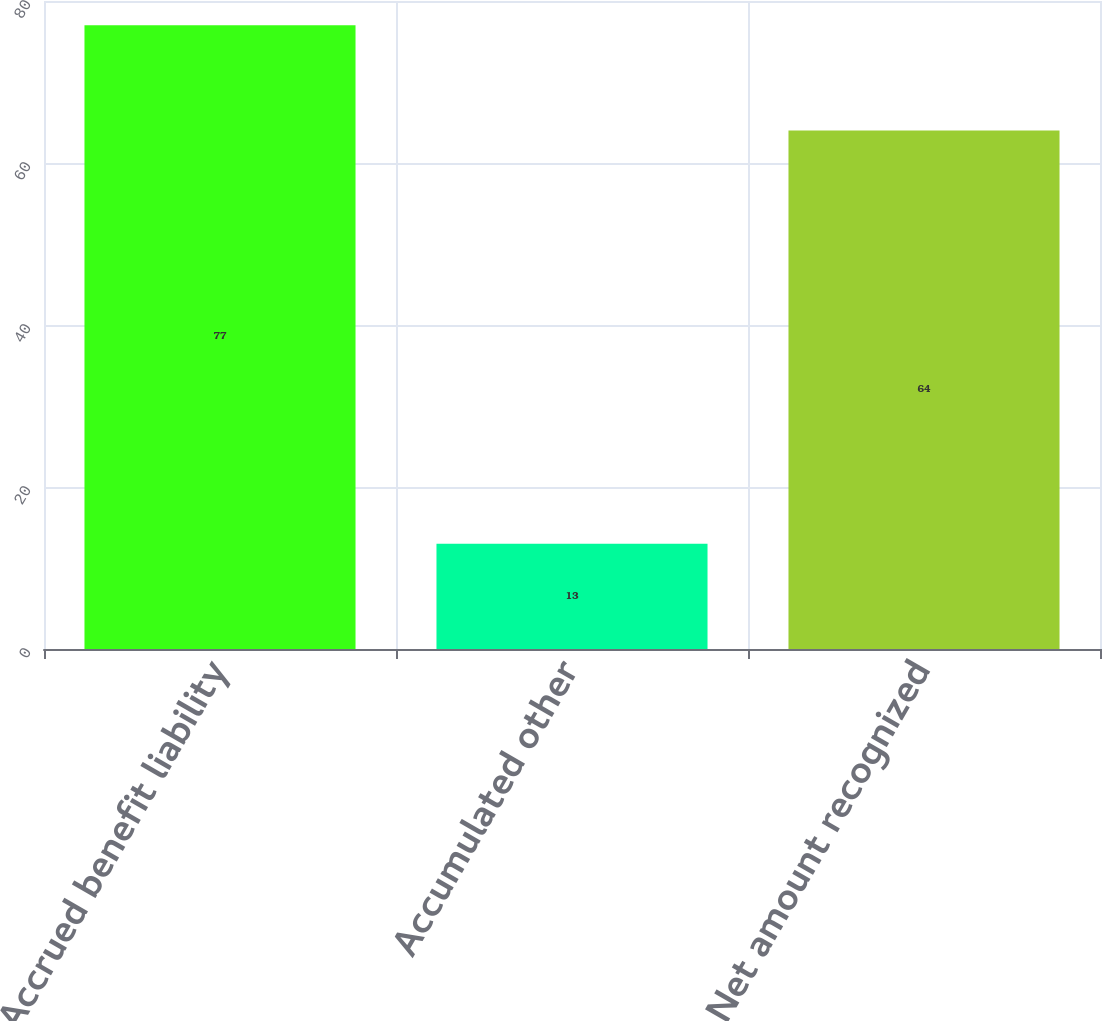<chart> <loc_0><loc_0><loc_500><loc_500><bar_chart><fcel>Accrued benefit liability<fcel>Accumulated other<fcel>Net amount recognized<nl><fcel>77<fcel>13<fcel>64<nl></chart> 